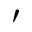Convert formula to latex. <formula><loc_0><loc_0><loc_500><loc_500>\prime</formula> 